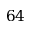Convert formula to latex. <formula><loc_0><loc_0><loc_500><loc_500>6 4</formula> 